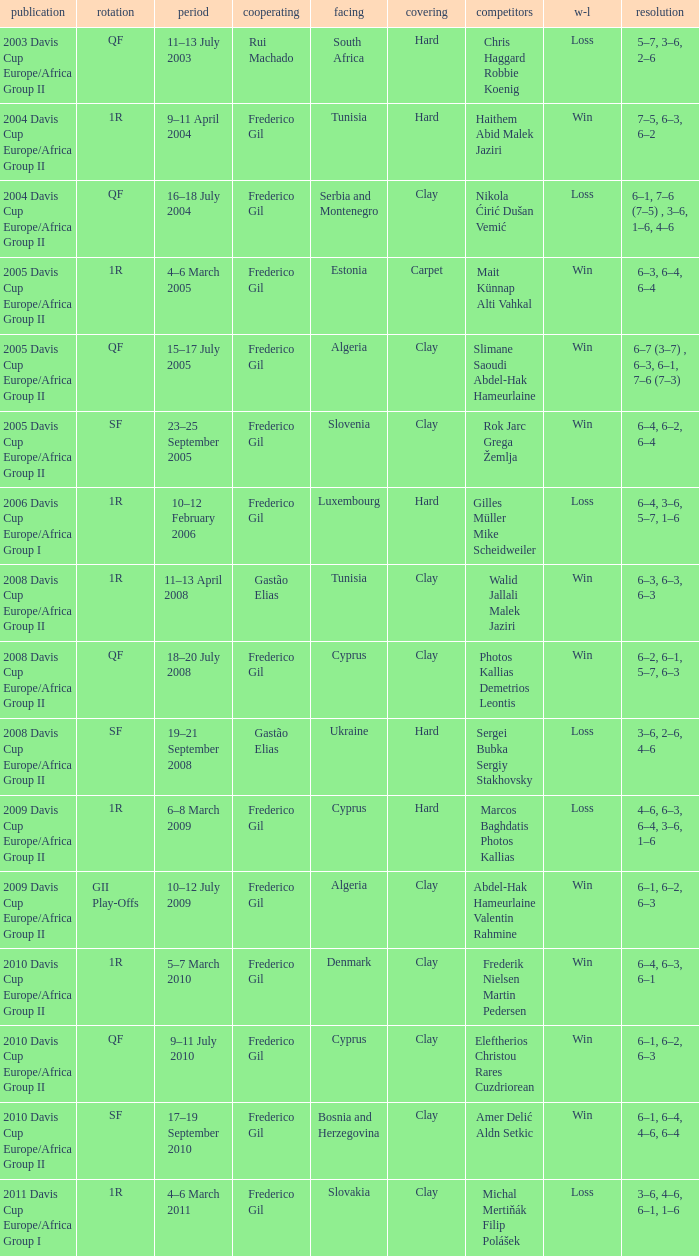How many rounds were there in the 2006 davis cup europe/africa group I? 1.0. 